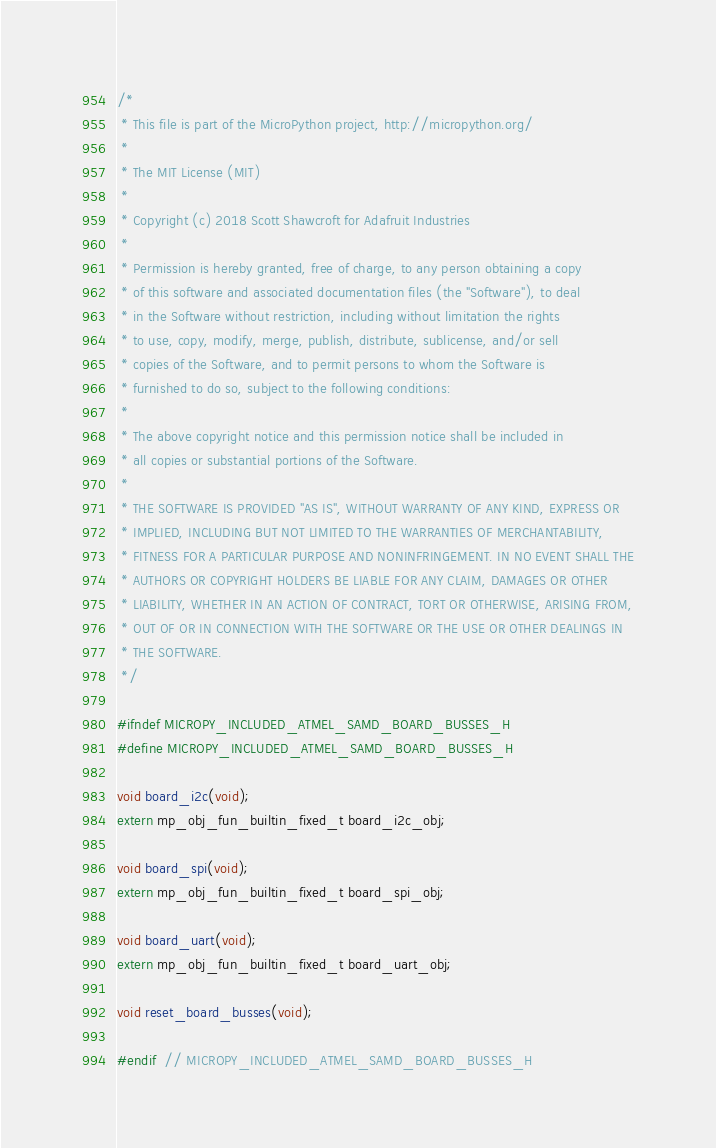Convert code to text. <code><loc_0><loc_0><loc_500><loc_500><_C_>/*
 * This file is part of the MicroPython project, http://micropython.org/
 *
 * The MIT License (MIT)
 *
 * Copyright (c) 2018 Scott Shawcroft for Adafruit Industries
 *
 * Permission is hereby granted, free of charge, to any person obtaining a copy
 * of this software and associated documentation files (the "Software"), to deal
 * in the Software without restriction, including without limitation the rights
 * to use, copy, modify, merge, publish, distribute, sublicense, and/or sell
 * copies of the Software, and to permit persons to whom the Software is
 * furnished to do so, subject to the following conditions:
 *
 * The above copyright notice and this permission notice shall be included in
 * all copies or substantial portions of the Software.
 *
 * THE SOFTWARE IS PROVIDED "AS IS", WITHOUT WARRANTY OF ANY KIND, EXPRESS OR
 * IMPLIED, INCLUDING BUT NOT LIMITED TO THE WARRANTIES OF MERCHANTABILITY,
 * FITNESS FOR A PARTICULAR PURPOSE AND NONINFRINGEMENT. IN NO EVENT SHALL THE
 * AUTHORS OR COPYRIGHT HOLDERS BE LIABLE FOR ANY CLAIM, DAMAGES OR OTHER
 * LIABILITY, WHETHER IN AN ACTION OF CONTRACT, TORT OR OTHERWISE, ARISING FROM,
 * OUT OF OR IN CONNECTION WITH THE SOFTWARE OR THE USE OR OTHER DEALINGS IN
 * THE SOFTWARE.
 */

#ifndef MICROPY_INCLUDED_ATMEL_SAMD_BOARD_BUSSES_H
#define MICROPY_INCLUDED_ATMEL_SAMD_BOARD_BUSSES_H

void board_i2c(void);
extern mp_obj_fun_builtin_fixed_t board_i2c_obj;

void board_spi(void);
extern mp_obj_fun_builtin_fixed_t board_spi_obj;

void board_uart(void);
extern mp_obj_fun_builtin_fixed_t board_uart_obj;

void reset_board_busses(void);

#endif  // MICROPY_INCLUDED_ATMEL_SAMD_BOARD_BUSSES_H
</code> 